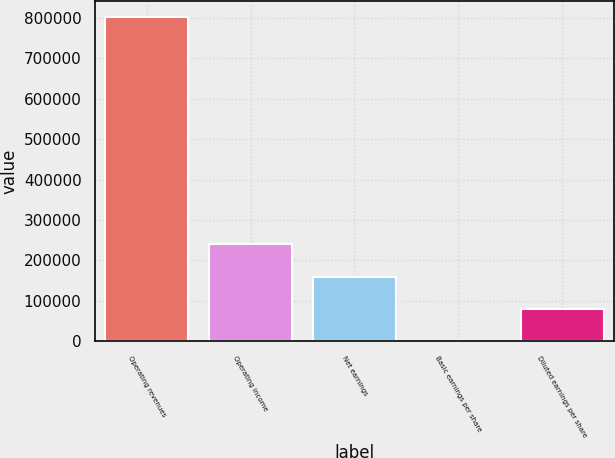Convert chart. <chart><loc_0><loc_0><loc_500><loc_500><bar_chart><fcel>Operating revenues<fcel>Operating income<fcel>Net earnings<fcel>Basic earnings per share<fcel>Diluted earnings per share<nl><fcel>801140<fcel>240342<fcel>160228<fcel>0.25<fcel>80114.2<nl></chart> 